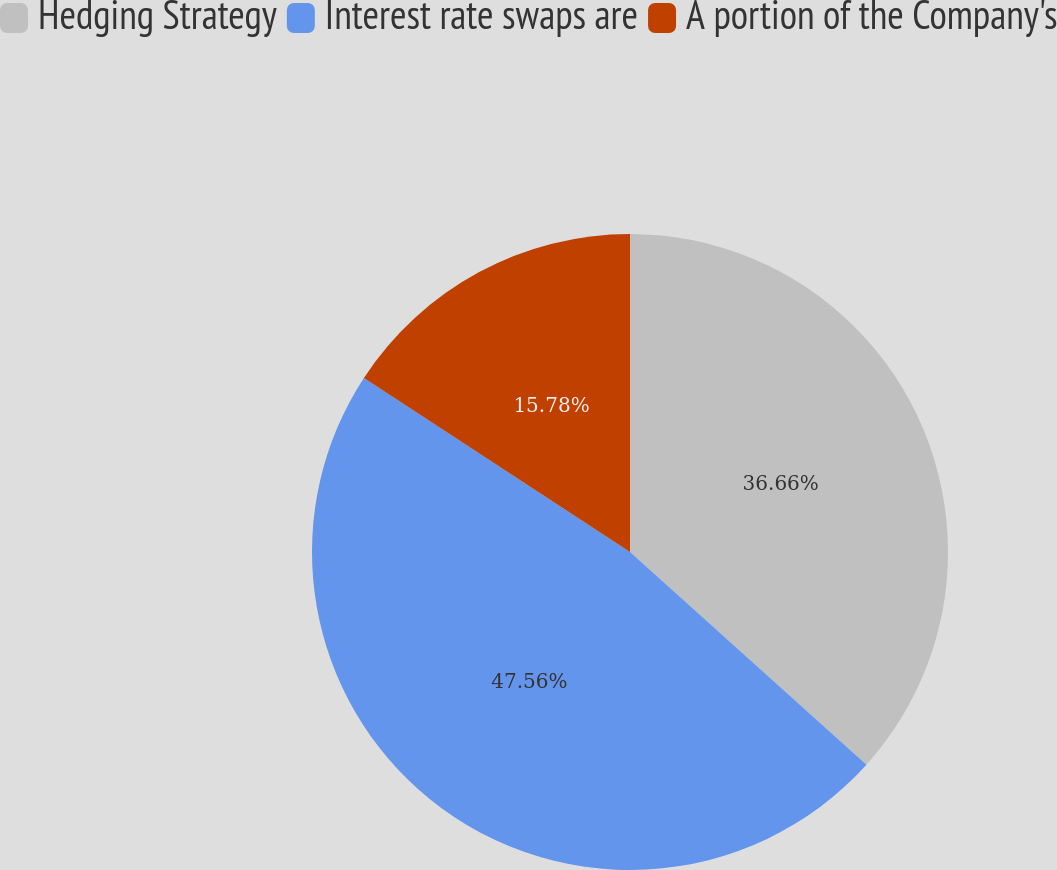Convert chart to OTSL. <chart><loc_0><loc_0><loc_500><loc_500><pie_chart><fcel>Hedging Strategy<fcel>Interest rate swaps are<fcel>A portion of the Company's<nl><fcel>36.66%<fcel>47.57%<fcel>15.78%<nl></chart> 